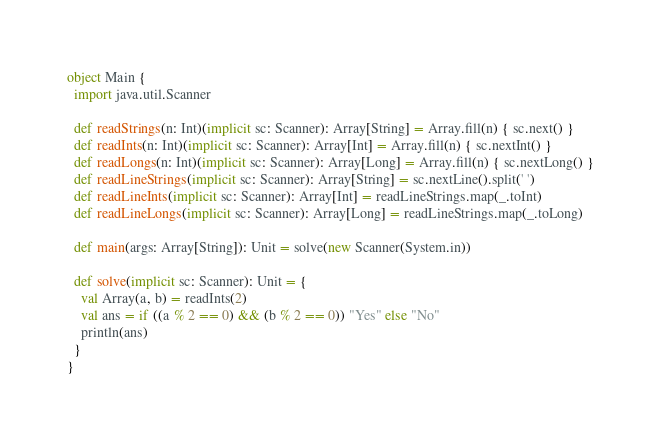<code> <loc_0><loc_0><loc_500><loc_500><_Scala_>object Main {
  import java.util.Scanner

  def readStrings(n: Int)(implicit sc: Scanner): Array[String] = Array.fill(n) { sc.next() }
  def readInts(n: Int)(implicit sc: Scanner): Array[Int] = Array.fill(n) { sc.nextInt() }
  def readLongs(n: Int)(implicit sc: Scanner): Array[Long] = Array.fill(n) { sc.nextLong() }
  def readLineStrings(implicit sc: Scanner): Array[String] = sc.nextLine().split(' ')
  def readLineInts(implicit sc: Scanner): Array[Int] = readLineStrings.map(_.toInt)
  def readLineLongs(implicit sc: Scanner): Array[Long] = readLineStrings.map(_.toLong)

  def main(args: Array[String]): Unit = solve(new Scanner(System.in))

  def solve(implicit sc: Scanner): Unit = {
    val Array(a, b) = readInts(2)
    val ans = if ((a % 2 == 0) && (b % 2 == 0)) "Yes" else "No"
    println(ans)
  }
}
</code> 